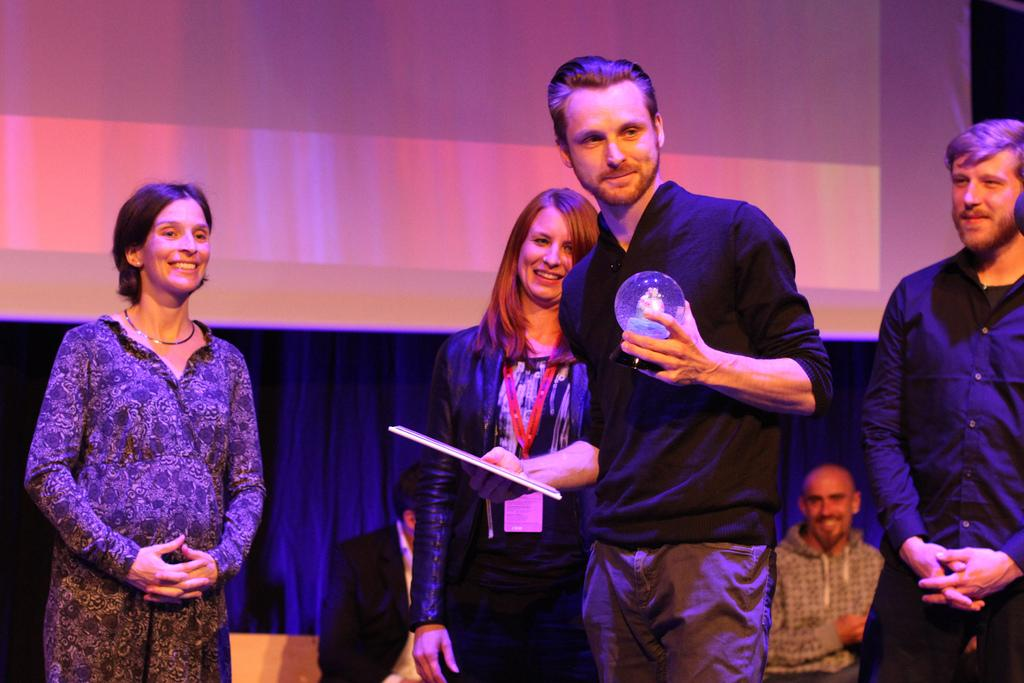What are the people in the image doing? Some people are standing, while others are sitting on chairs in the image. Can you describe any objects that people are holding in the image? Yes, a person is holding a ball, and another person is holding a paper in the image. What can be seen in the background of the image? There is a screen and a blue curtain visible in the background of the image. What type of bait is being used to catch fish in the image? There is no mention of fishing or bait in the image; it features people standing, sitting, and holding objects. Can you tell me who the manager is in the image? There is no indication of a manager or any hierarchical roles in the image. 